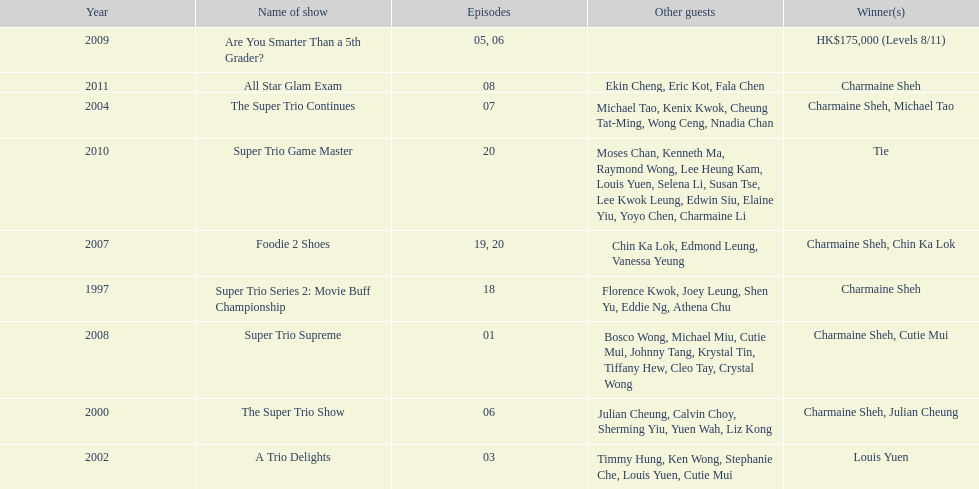How many of shows had at least 5 episodes? 7. 